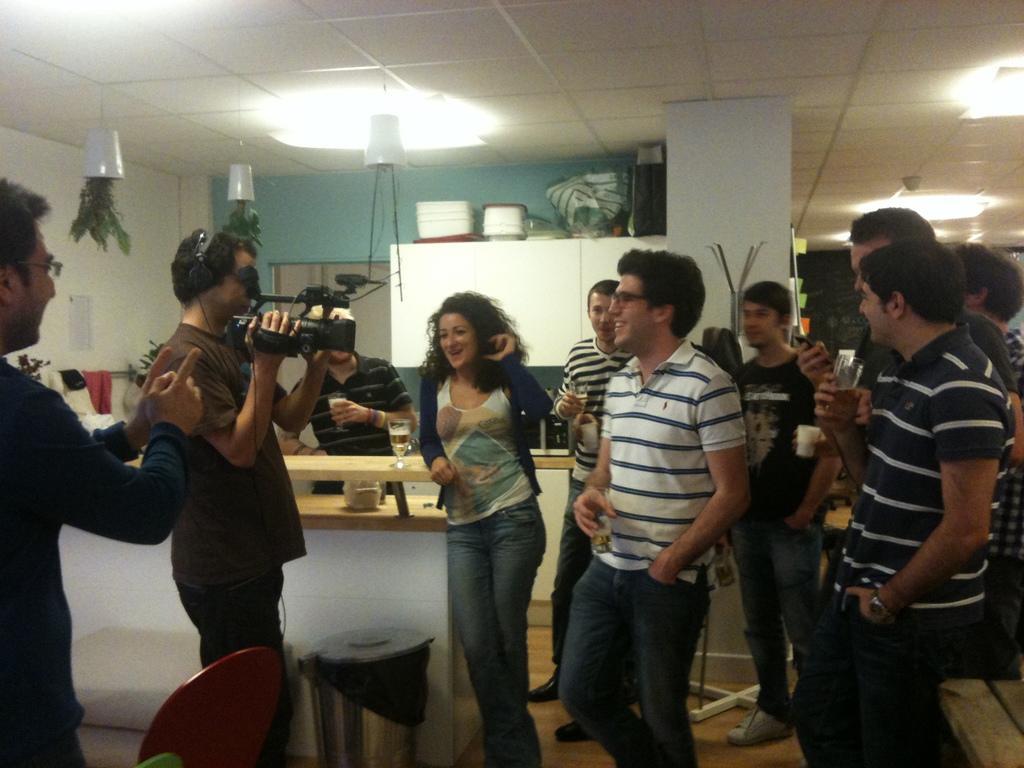In one or two sentences, can you explain what this image depicts? In this image there are a group of people one person is holding a camera, and rest of them are holding glasses. At the bottom there is floor, and we could see chair, stool, table, glasses, flower pot, plants, cupboard, door, wall, poster and objects. At the top there is ceiling and lights. 